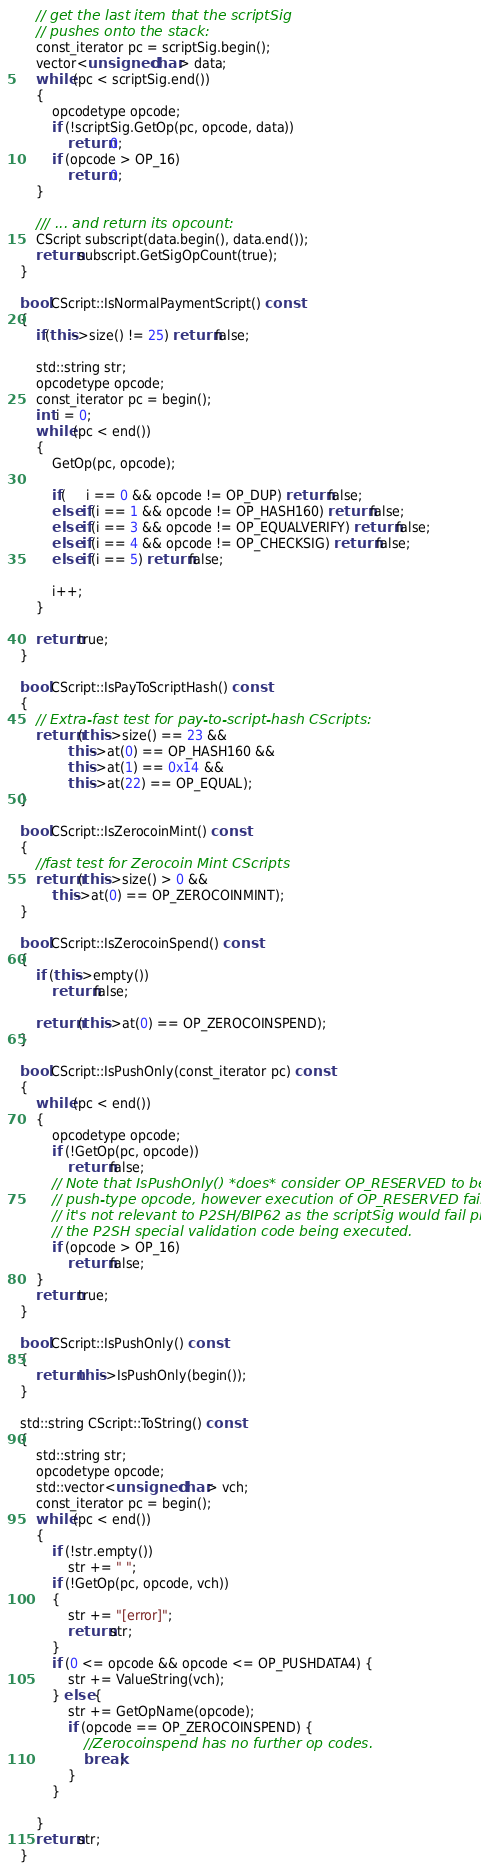<code> <loc_0><loc_0><loc_500><loc_500><_C++_>    // get the last item that the scriptSig
    // pushes onto the stack:
    const_iterator pc = scriptSig.begin();
    vector<unsigned char> data;
    while (pc < scriptSig.end())
    {
        opcodetype opcode;
        if (!scriptSig.GetOp(pc, opcode, data))
            return 0;
        if (opcode > OP_16)
            return 0;
    }

    /// ... and return its opcount:
    CScript subscript(data.begin(), data.end());
    return subscript.GetSigOpCount(true);
}

bool CScript::IsNormalPaymentScript() const
{
    if(this->size() != 25) return false;

    std::string str;
    opcodetype opcode;
    const_iterator pc = begin();
    int i = 0;
    while (pc < end())
    {
        GetOp(pc, opcode);

        if(     i == 0 && opcode != OP_DUP) return false;
        else if(i == 1 && opcode != OP_HASH160) return false;
        else if(i == 3 && opcode != OP_EQUALVERIFY) return false;
        else if(i == 4 && opcode != OP_CHECKSIG) return false;
        else if(i == 5) return false;

        i++;
    }

    return true;
}

bool CScript::IsPayToScriptHash() const
{
    // Extra-fast test for pay-to-script-hash CScripts:
    return (this->size() == 23 &&
            this->at(0) == OP_HASH160 &&
            this->at(1) == 0x14 &&
            this->at(22) == OP_EQUAL);
}

bool CScript::IsZerocoinMint() const
{
    //fast test for Zerocoin Mint CScripts
    return (this->size() > 0 &&
        this->at(0) == OP_ZEROCOINMINT);
}

bool CScript::IsZerocoinSpend() const
{
    if (this->empty())
        return false;

    return (this->at(0) == OP_ZEROCOINSPEND);
}

bool CScript::IsPushOnly(const_iterator pc) const
{
    while (pc < end())
    {
        opcodetype opcode;
        if (!GetOp(pc, opcode))
            return false;
        // Note that IsPushOnly() *does* consider OP_RESERVED to be a
        // push-type opcode, however execution of OP_RESERVED fails, so
        // it's not relevant to P2SH/BIP62 as the scriptSig would fail prior to
        // the P2SH special validation code being executed.
        if (opcode > OP_16)
            return false;
    }
    return true;
}

bool CScript::IsPushOnly() const
{
    return this->IsPushOnly(begin());
}

std::string CScript::ToString() const
{
    std::string str;
    opcodetype opcode;
    std::vector<unsigned char> vch;
    const_iterator pc = begin();
    while (pc < end())
    {
        if (!str.empty())
            str += " ";
        if (!GetOp(pc, opcode, vch))
        {
            str += "[error]";
            return str;
        }
        if (0 <= opcode && opcode <= OP_PUSHDATA4) {
            str += ValueString(vch);
        } else {
            str += GetOpName(opcode);
            if (opcode == OP_ZEROCOINSPEND) {
                //Zerocoinspend has no further op codes.
                break;
            }
        }

    }
    return str;
}
</code> 